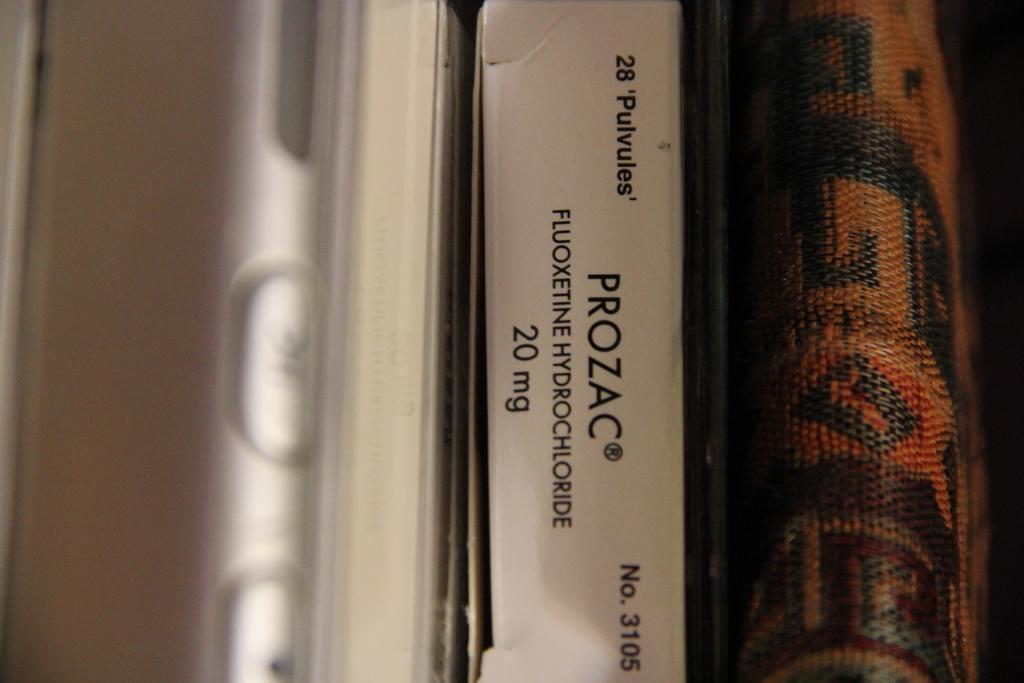<image>
Present a compact description of the photo's key features. A row of binders with and a package of 20 mg Prozac. 